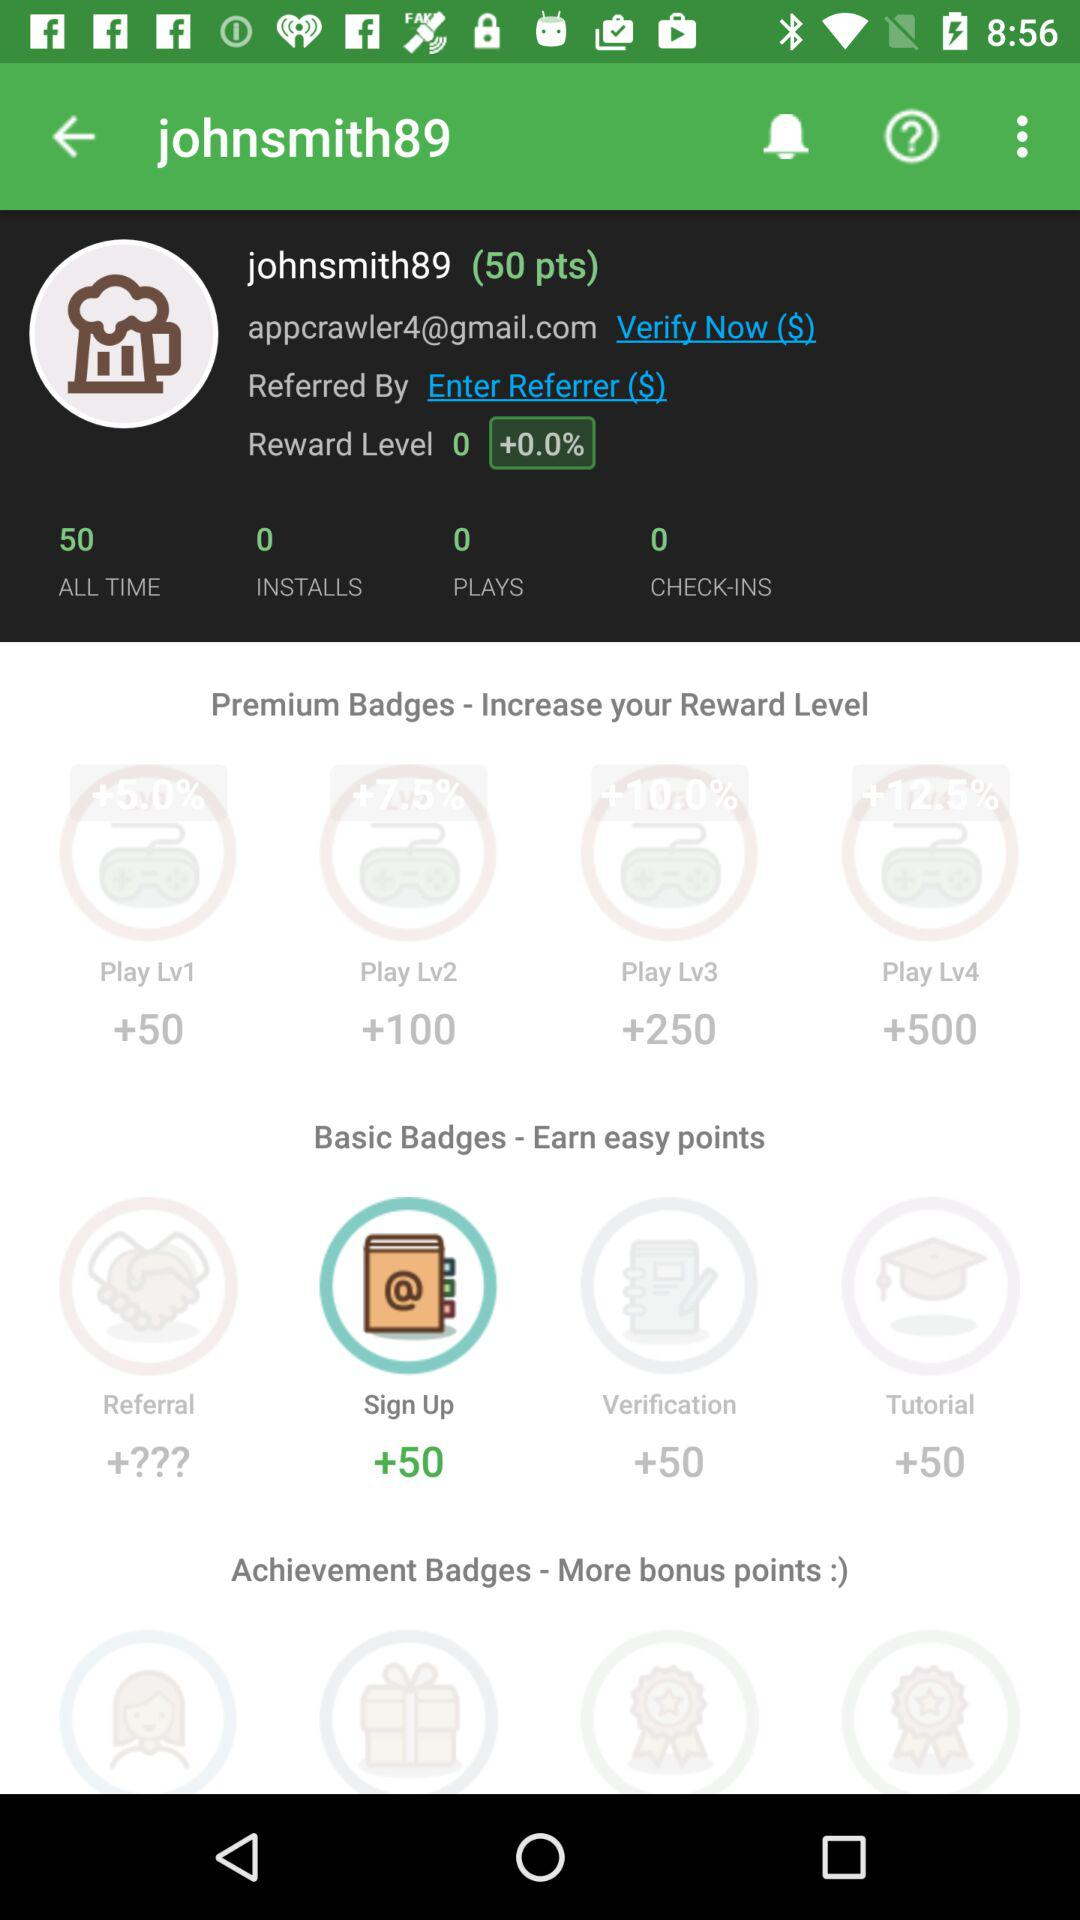What is the name of user? The name of the user is johnsmith89. 